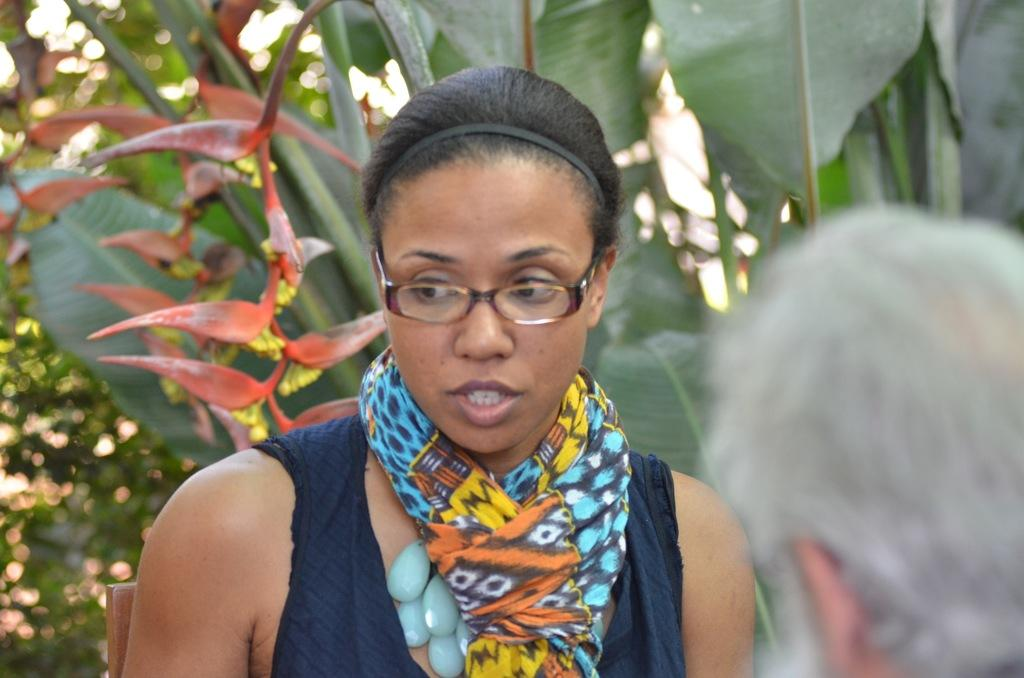Who is present in the image? There is a woman in the image. What is the woman doing in the image? There is a person standing in the image, which implies that the woman is standing. What can be seen in the background of the image? There are plants and trees in the background of the image. How would you describe the background of the image? The background of the image is slightly blurred. What type of vest is the flock wearing in the image? There is no flock or vest present in the image. 